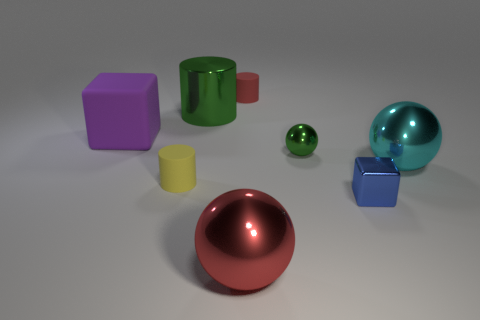Subtract all shiny cylinders. How many cylinders are left? 2 Subtract all blocks. How many objects are left? 6 Subtract 1 spheres. How many spheres are left? 2 Add 1 large green metal cylinders. How many objects exist? 9 Subtract all blue blocks. How many blocks are left? 1 Subtract 0 brown blocks. How many objects are left? 8 Subtract all yellow cylinders. Subtract all blue spheres. How many cylinders are left? 2 Subtract all gray balls. How many cyan cylinders are left? 0 Subtract all green cylinders. Subtract all big shiny balls. How many objects are left? 5 Add 8 small balls. How many small balls are left? 9 